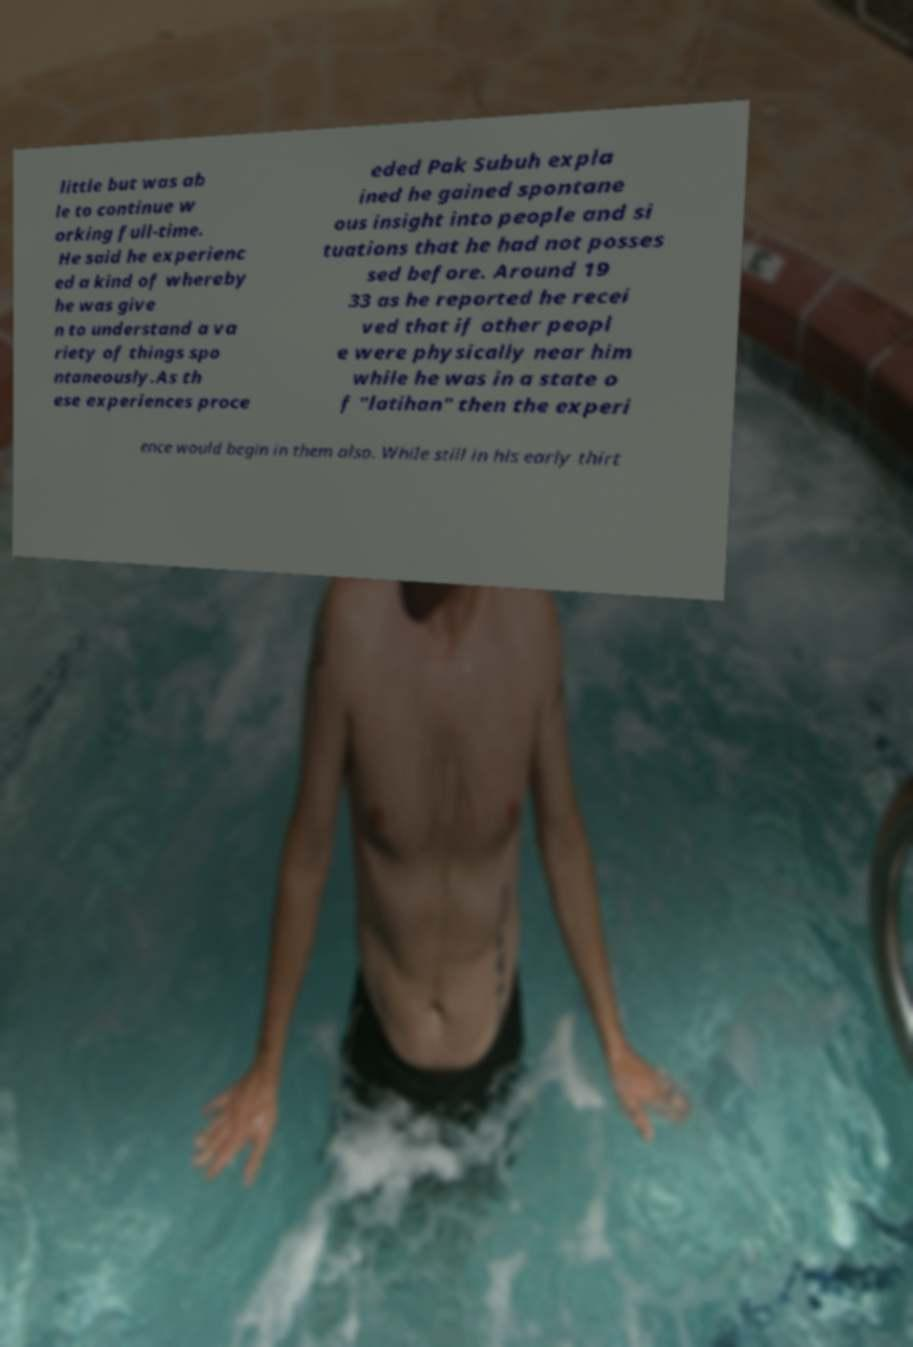Could you assist in decoding the text presented in this image and type it out clearly? little but was ab le to continue w orking full-time. He said he experienc ed a kind of whereby he was give n to understand a va riety of things spo ntaneously.As th ese experiences proce eded Pak Subuh expla ined he gained spontane ous insight into people and si tuations that he had not posses sed before. Around 19 33 as he reported he recei ved that if other peopl e were physically near him while he was in a state o f "latihan" then the experi ence would begin in them also. While still in his early thirt 